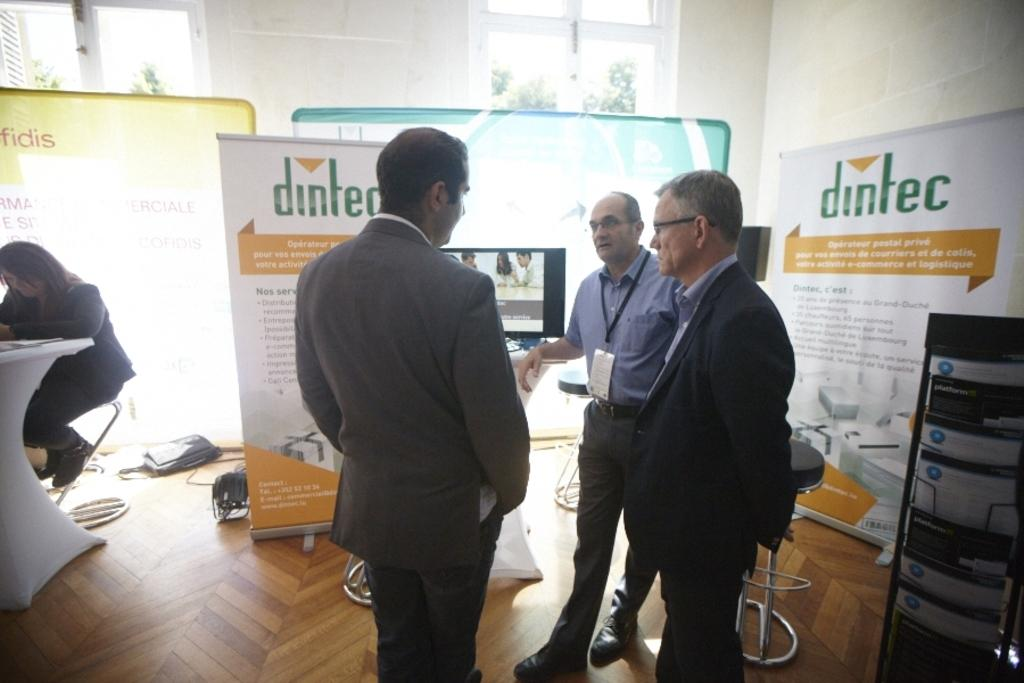How many people are present in the image? There are four persons in the image. Where are the persons located in the image? The persons are on the floor, table, and chairs. What can be seen on the walls and surfaces in the image? There are boards and posters visible in the image. What is visible on the walls in the image? There is a wall visible in the image. What can be seen through the windows in the image? Trees are visible through the windows. What type of location might the image have been taken in? The image may have been taken in a hall. What type of wave can be seen crashing on the shore in the image? There is no wave or shore present in the image; it features four persons in a hall with boards, posters, walls, windows, and trees. 